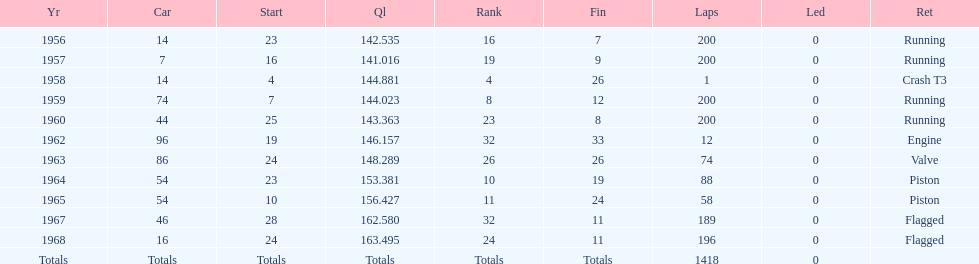How many times did he finish all 200 laps? 4. 